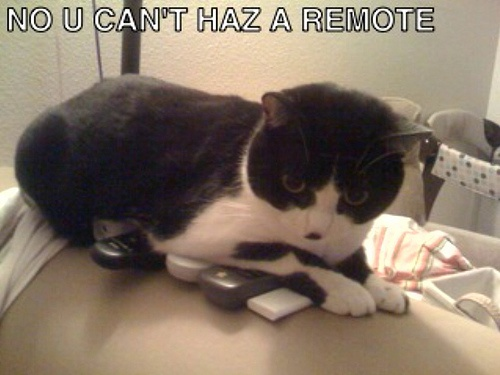Describe the objects in this image and their specific colors. I can see cat in tan, black, and gray tones, bed in tan and gray tones, couch in tan and gray tones, remote in tan, black, gray, and maroon tones, and remote in tan, black, and gray tones in this image. 